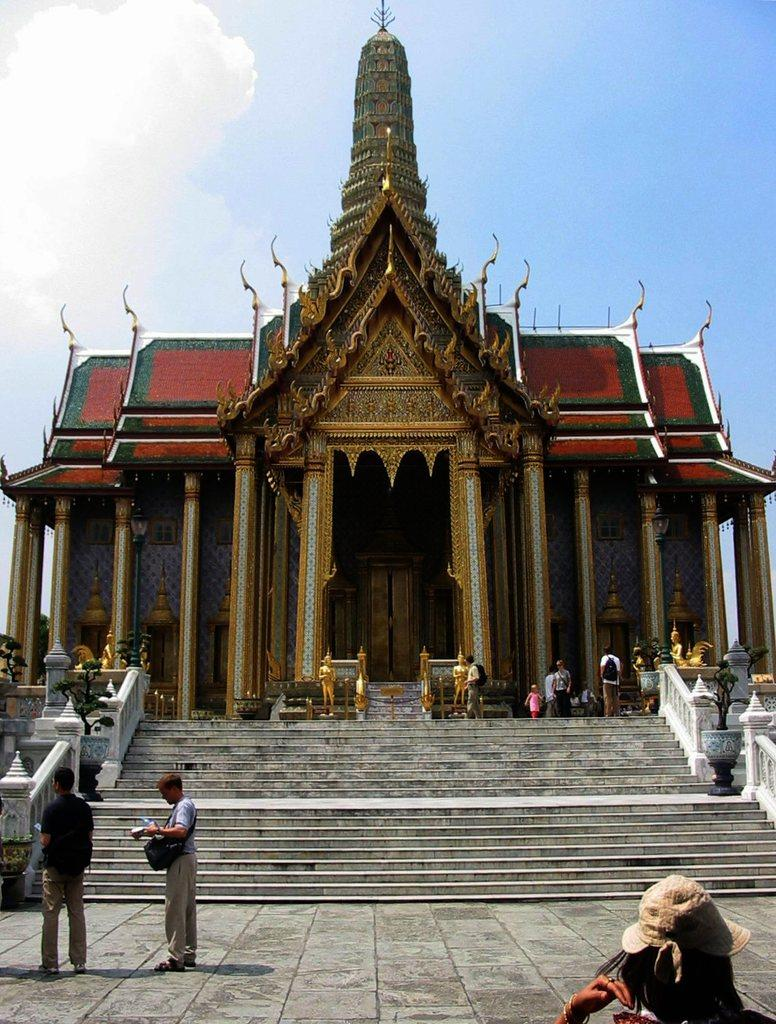Who or what can be seen in the image? There are people in the image. What is the location of the people in the image? The people are standing in front of a temple. What can be seen in the background of the image? There is a blue sky visible in the background of the image. Are there any cacti growing in the temple in the image? There is no mention of cacti in the image, and they are not visible in the provided facts. 